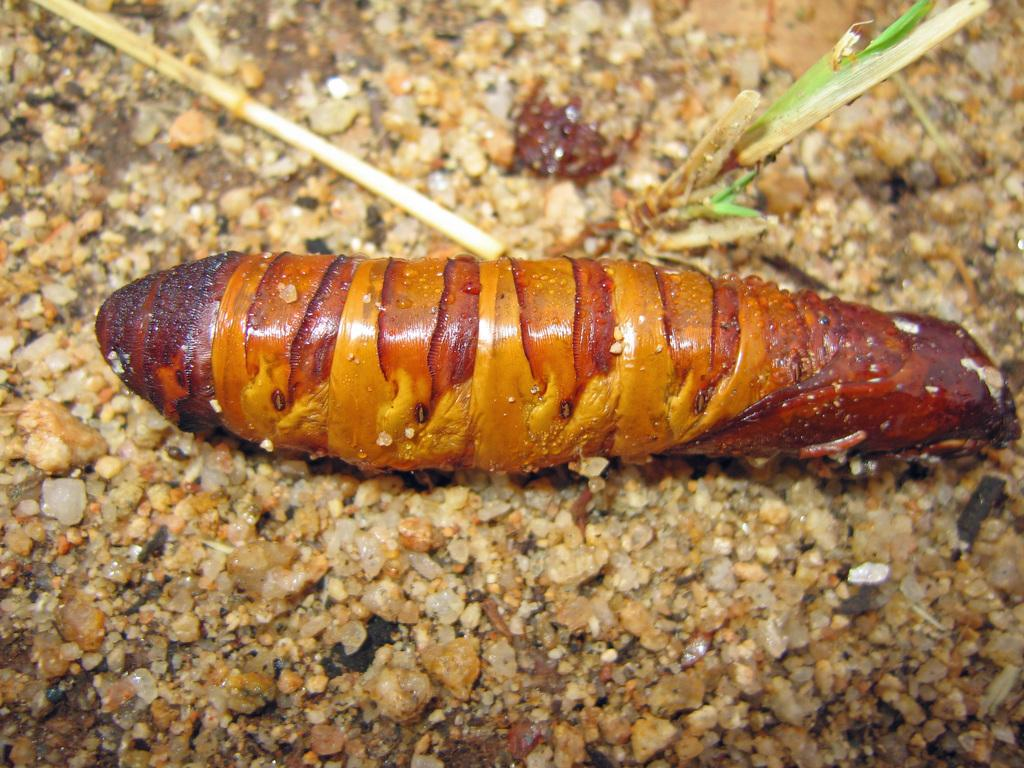What type of natural elements can be seen in the image? There are stones in the image. What is the color of the brown-colored object in the image? The brown-colored object in the image is brown. What type of plant material is present in the image? There is a green-colored leaf in the image. What is the price of the engine in the image? There is no engine present in the image, so it is not possible to determine its price. 